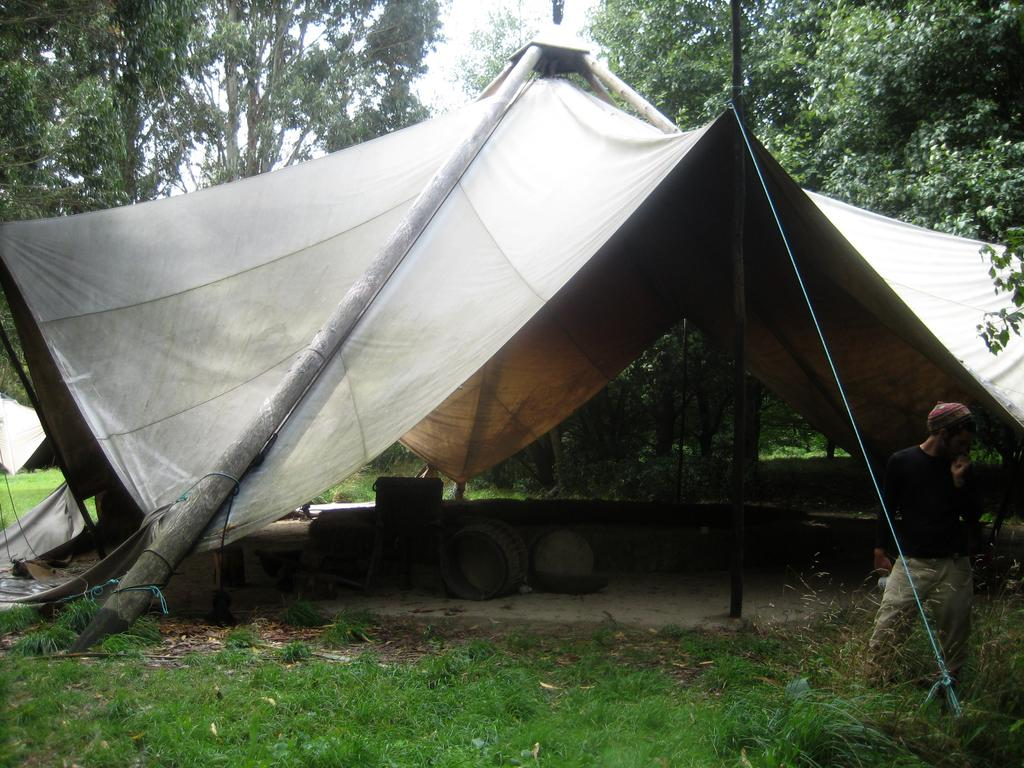What type of setting is depicted in the image? There is a camp in the image. What is located beneath the camp? There are objects beneath the camp. Can you describe the person in the image? There is a person standing on the grass. What type of vegetation is visible in the image? The grass is visible in the image. What can be seen in the background of the image? There are trees in the background of the image. What type of joke is the person telling in the image? There is no indication in the image that the person is telling a joke, so it cannot be determined from the picture. 